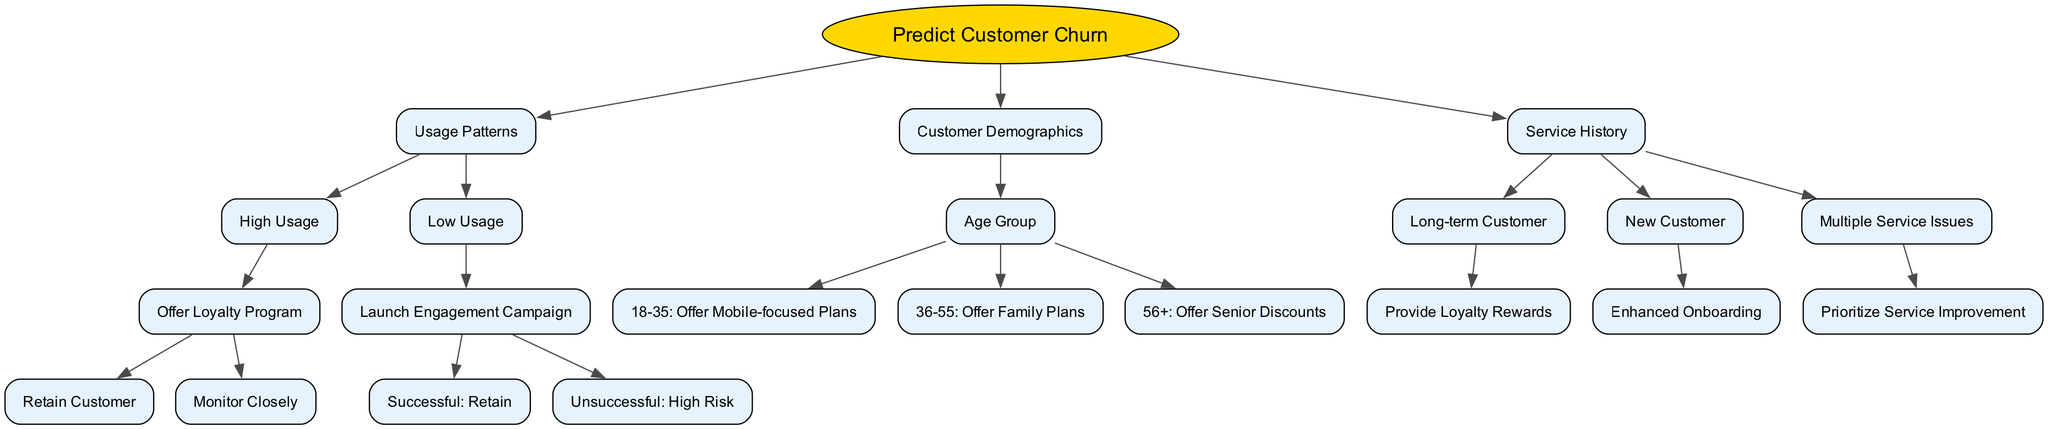What is the root node's text? The root node represents the main prediction goal of the decision tree, which is to "Predict Customer Churn".
Answer: Predict Customer Churn How many main branches are there from the root node? The root node branches into three major categories: Usage Patterns, Customer Demographics, and Service History. Therefore, there are three main branches.
Answer: 3 What happens if a customer has low usage? If a customer has low usage, the decision tree recommends launching an engagement campaign. This action leads to either success in retaining the customer or being classified as high risk if unsuccessful.
Answer: Launch Engagement Campaign What is recommended for long-term customers? For long-term customers, the recommendation is to provide loyalty rewards in order to retain them.
Answer: Provide Loyalty Rewards At what age group should mobile-focused plans be offered? Mobile-focused plans should be offered to customers in the age group of 18 to 35.
Answer: 18-35 If a customer has multiple service issues, what action should be taken? The decision tree indicates that the action to take for customers with multiple service issues is to prioritize service improvement.
Answer: Prioritize Service Improvement What is the outcome if a high usage customer is offered a loyalty program? If a high usage customer is offered a loyalty program, the possible outcomes are retaining the customer or monitoring them closely if their status is uncertain.
Answer: Retain Customer or Monitor Closely Which demographics category includes the recommendation of senior discounts? The recommendation of senior discounts falls under the Customer Demographics category, specifically for customers who are in the 56+ age group.
Answer: 56+ If a new customer is identified, what approach is recommended? The recommendation for new customers is to enhance their onboarding process to improve their experience with the service.
Answer: Enhanced Onboarding 